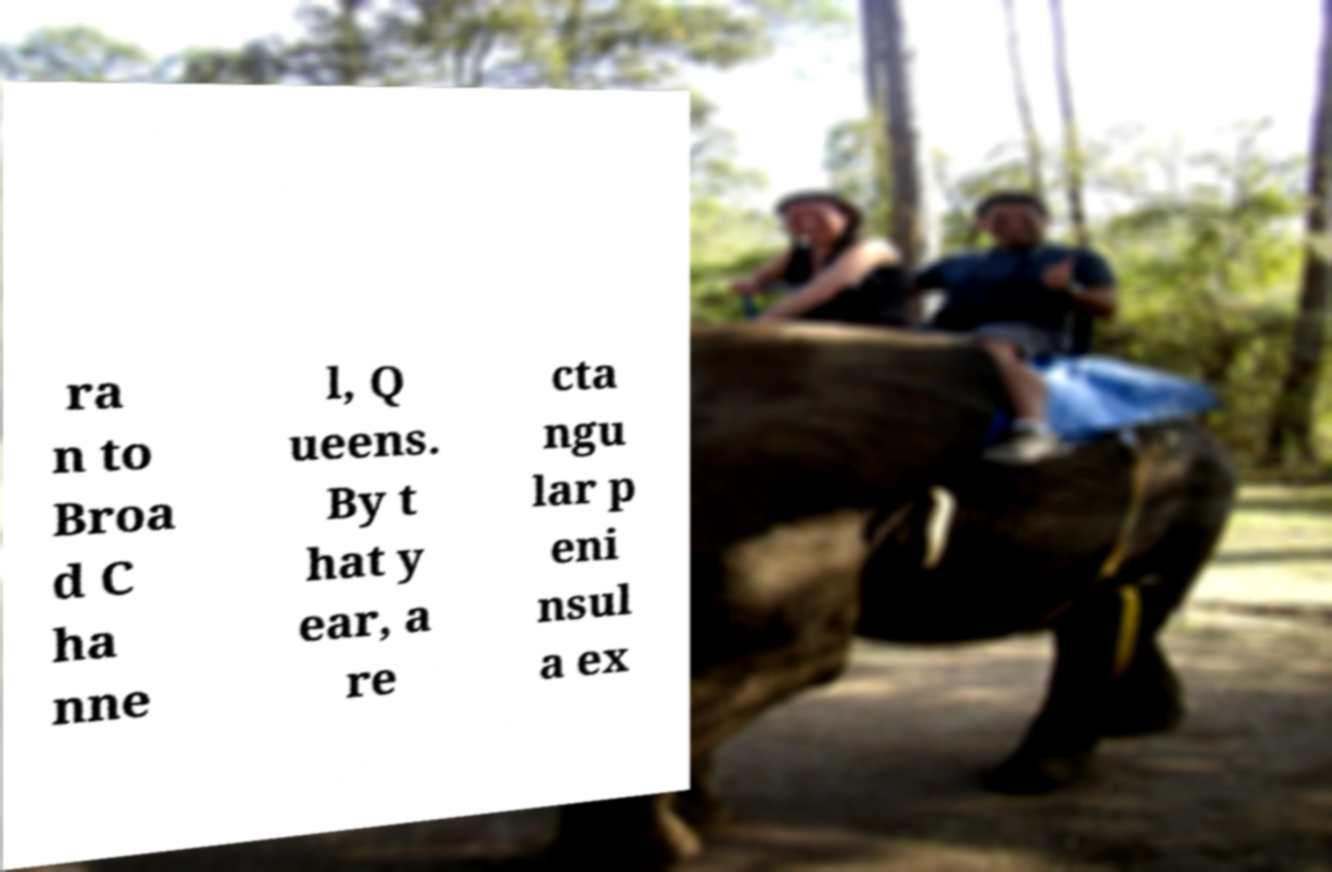For documentation purposes, I need the text within this image transcribed. Could you provide that? ra n to Broa d C ha nne l, Q ueens. By t hat y ear, a re cta ngu lar p eni nsul a ex 